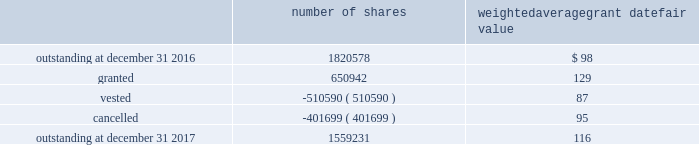In 2017 , the company granted 440076 shares of restricted class a common stock and 7568 shares of restricted stock units .
Restricted common stock and restricted stock units generally have a vesting period of two to four years .
The fair value related to these grants was $ 58.7 million , which is recognized as compensation expense on an accelerated basis over the vesting period .
Dividends are accrued on restricted class a common stock and restricted stock units and are paid once the restricted stock vests .
In 2017 , the company also granted 203298 performance shares .
The fair value related to these grants was $ 25.3 million , which is recognized as compensation expense on an accelerated and straight-lined basis over the vesting period .
The vesting of these shares is contingent on meeting stated performance or market conditions .
The table summarizes restricted stock , restricted stock units , and performance shares activity for 2017 : number of shares weighted average grant date fair value .
The total fair value of restricted stock , restricted stock units , and performance shares that vested during 2017 , 2016 and 2015 was $ 66.0 million , $ 59.8 million and $ 43.3 million , respectively .
Under the espp , eligible employees may acquire shares of class a common stock using after-tax payroll deductions made during consecutive offering periods of approximately six months in duration .
Shares are purchased at the end of each offering period at a price of 90% ( 90 % ) of the closing price of the class a common stock as reported on the nasdaq global select market .
Compensation expense is recognized on the dates of purchase for the discount from the closing price .
In 2017 , 2016 and 2015 , a total of 19936 , 19858 and 19756 shares , respectively , of class a common stock were issued to participating employees .
These shares are subject to a six-month holding period .
Annual expense of $ 0.3 million for the purchase discount was recognized in 2017 , and $ 0.2 million was recognized in both 2016 and 2015 .
Non-executive directors receive an annual award of class a common stock with a value equal to $ 100000 .
Non-executive directors may also elect to receive some or all of the cash portion of their annual stipend , up to $ 60000 , in shares of stock based on the closing price at the date of distribution .
As a result , 19736 shares , 26439 shares and 25853 shares of class a common stock were issued to non-executive directors during 2017 , 2016 and 2015 , respectively .
These shares are not subject to any vesting restrictions .
Expense of $ 2.5 million , $ 2.4 million and $ 2.5 million related to these stock-based payments was recognized for the years ended december 31 , 2017 , 2016 and 2015 , respectively. .
What is the ratio of perfomance shares as a percent of the total number of granted shares? 
Rationale: its the division of the number of perfomance shares ( 203298 ) by the total number of granted shares ( 650942 ) .
Computations: (203298 / 650942)
Answer: 0.31231. 